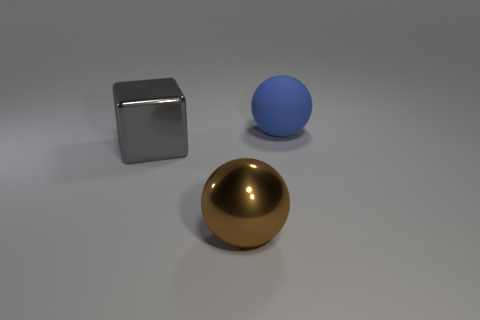Add 3 green matte objects. How many objects exist? 6 Add 1 big gray shiny objects. How many big gray shiny objects are left? 2 Add 3 cyan matte balls. How many cyan matte balls exist? 3 Subtract 0 gray spheres. How many objects are left? 3 Subtract all blocks. How many objects are left? 2 Subtract all blue cubes. Subtract all green balls. How many cubes are left? 1 Subtract all gray metal cubes. Subtract all metallic blocks. How many objects are left? 1 